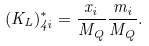Convert formula to latex. <formula><loc_0><loc_0><loc_500><loc_500>( K _ { L } ) ^ { * } _ { 4 i } = \frac { x _ { i } } { M _ { Q } } \frac { m _ { i } } { M _ { Q } } .</formula> 